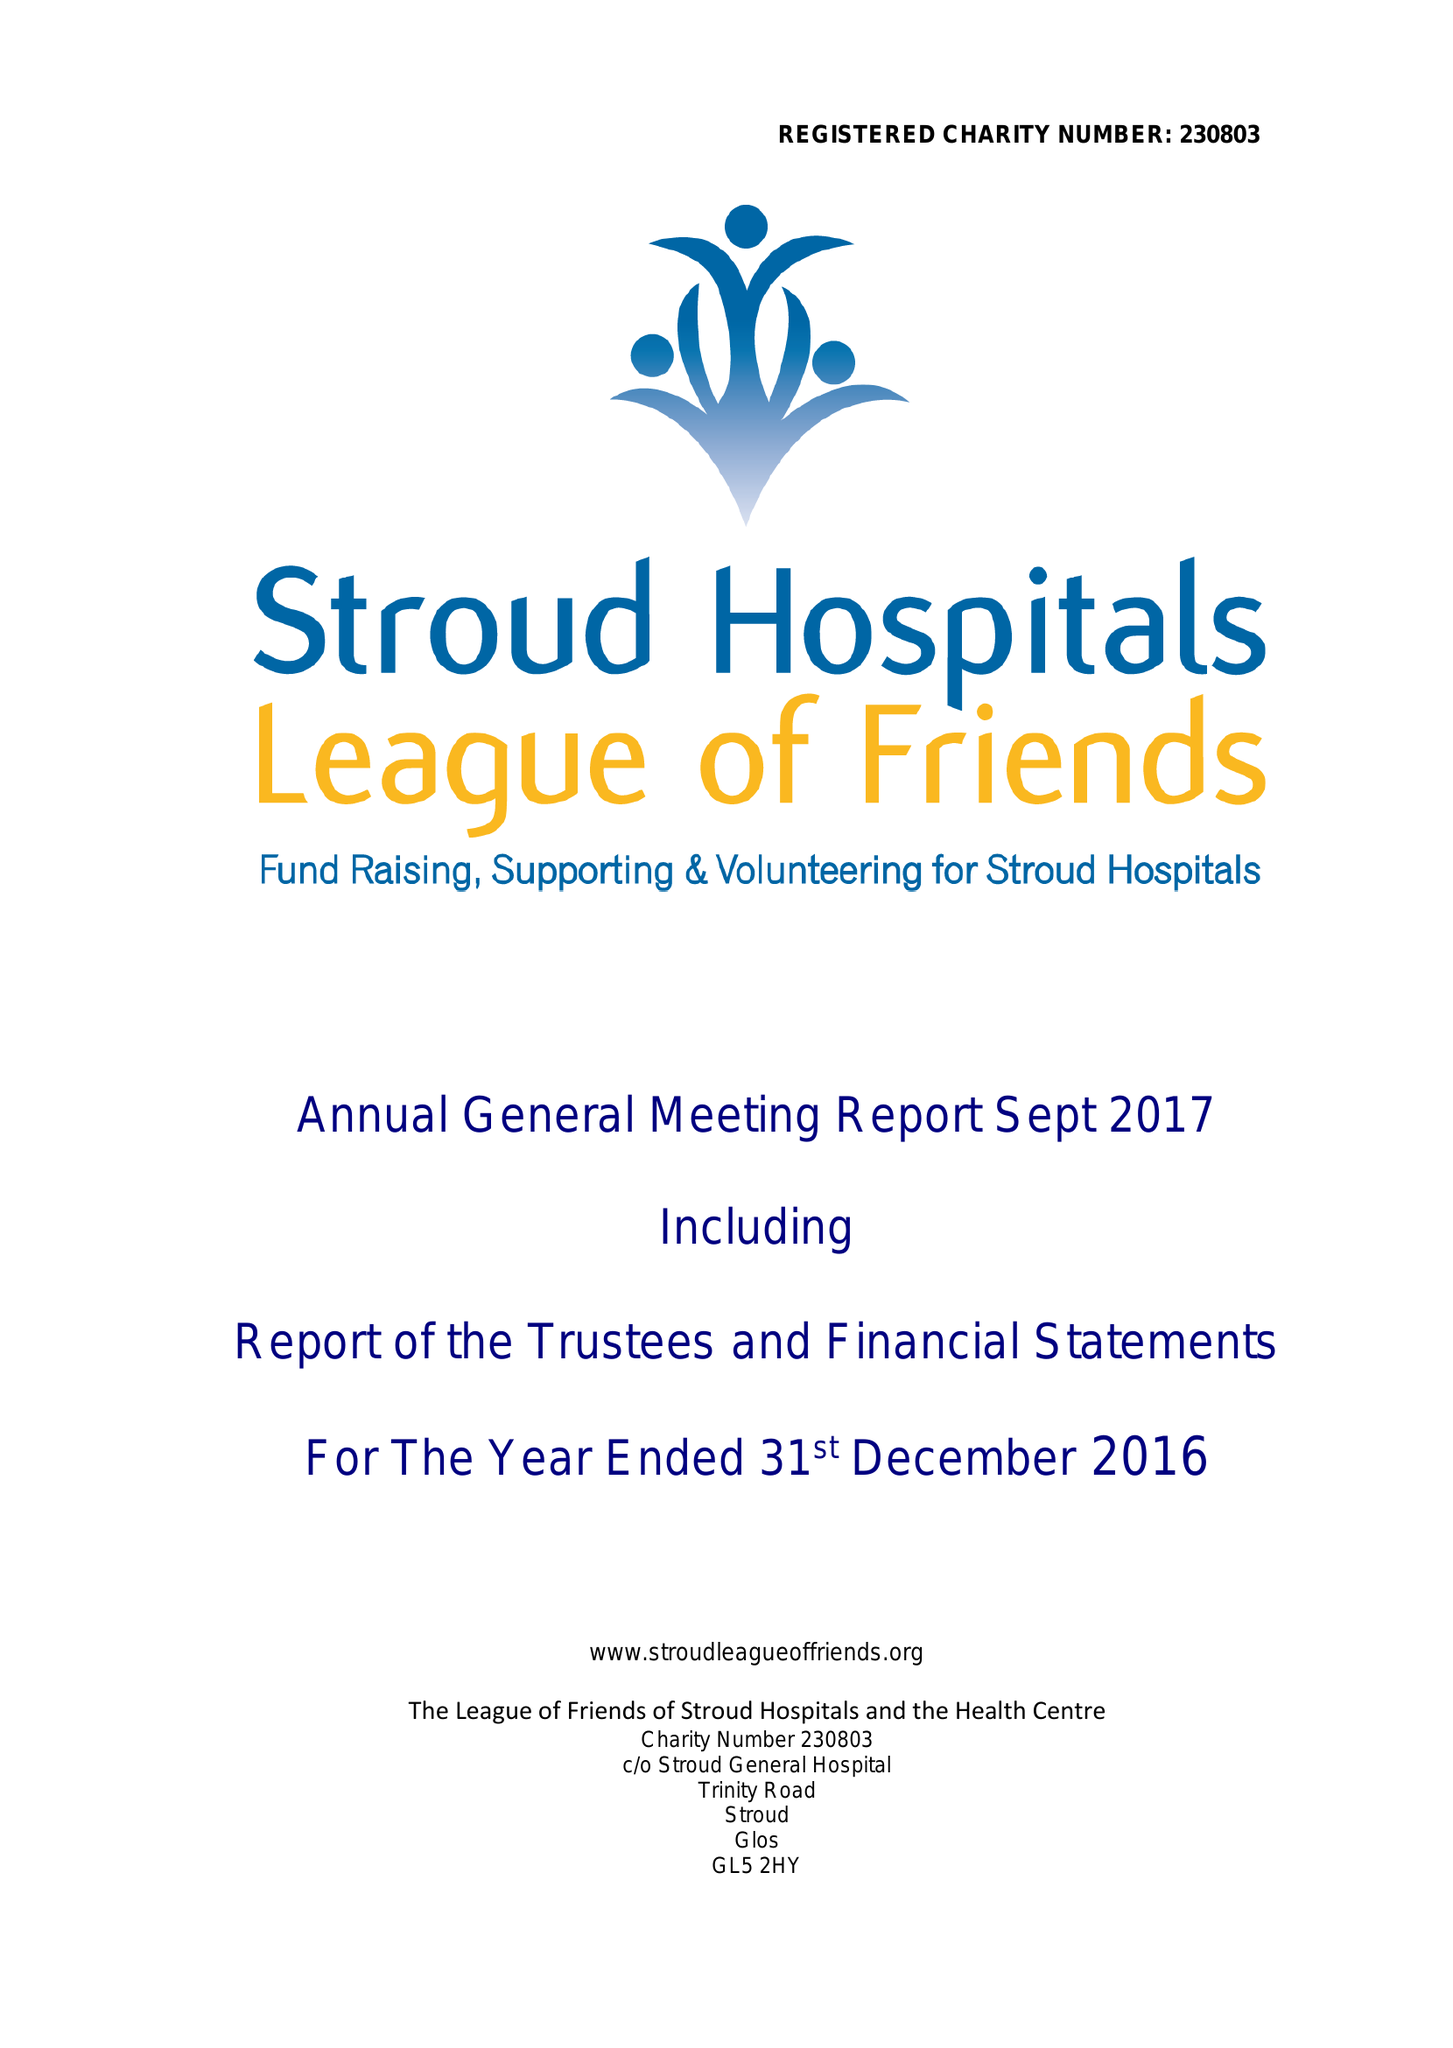What is the value for the address__post_town?
Answer the question using a single word or phrase. STROUD 